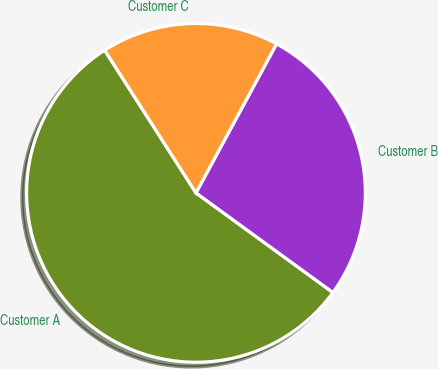Convert chart. <chart><loc_0><loc_0><loc_500><loc_500><pie_chart><fcel>Customer A<fcel>Customer B<fcel>Customer C<nl><fcel>55.93%<fcel>27.12%<fcel>16.95%<nl></chart> 